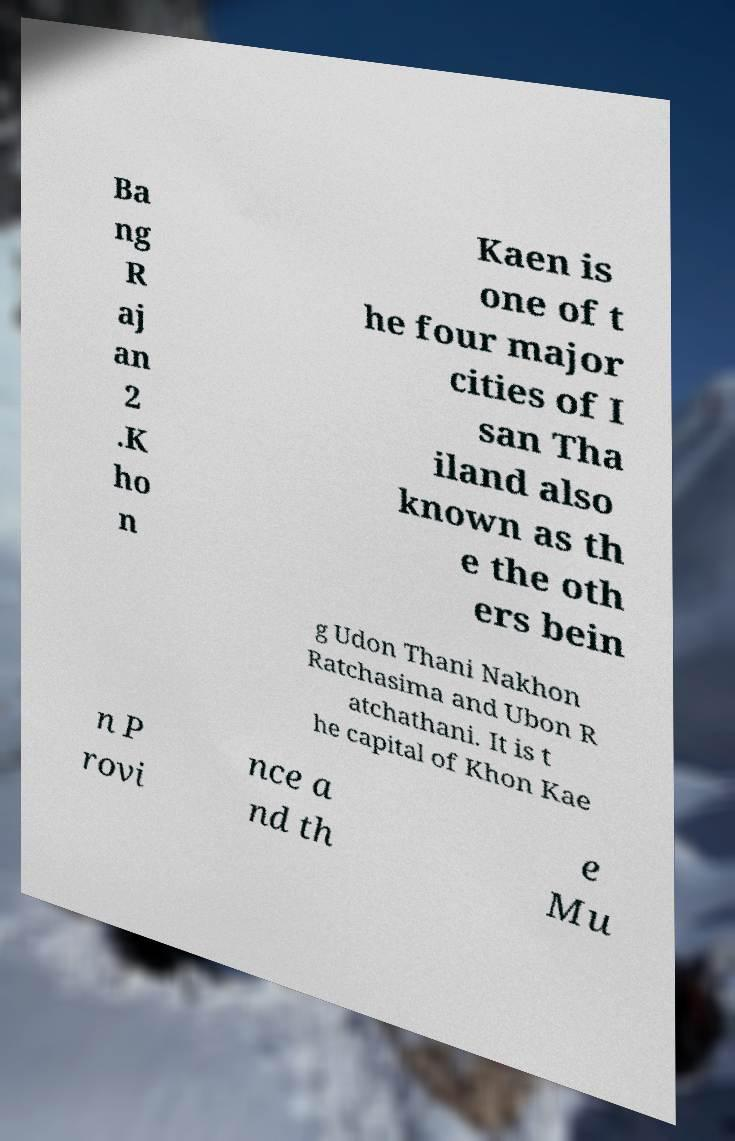Please read and relay the text visible in this image. What does it say? Ba ng R aj an 2 .K ho n Kaen is one of t he four major cities of I san Tha iland also known as th e the oth ers bein g Udon Thani Nakhon Ratchasima and Ubon R atchathani. It is t he capital of Khon Kae n P rovi nce a nd th e Mu 